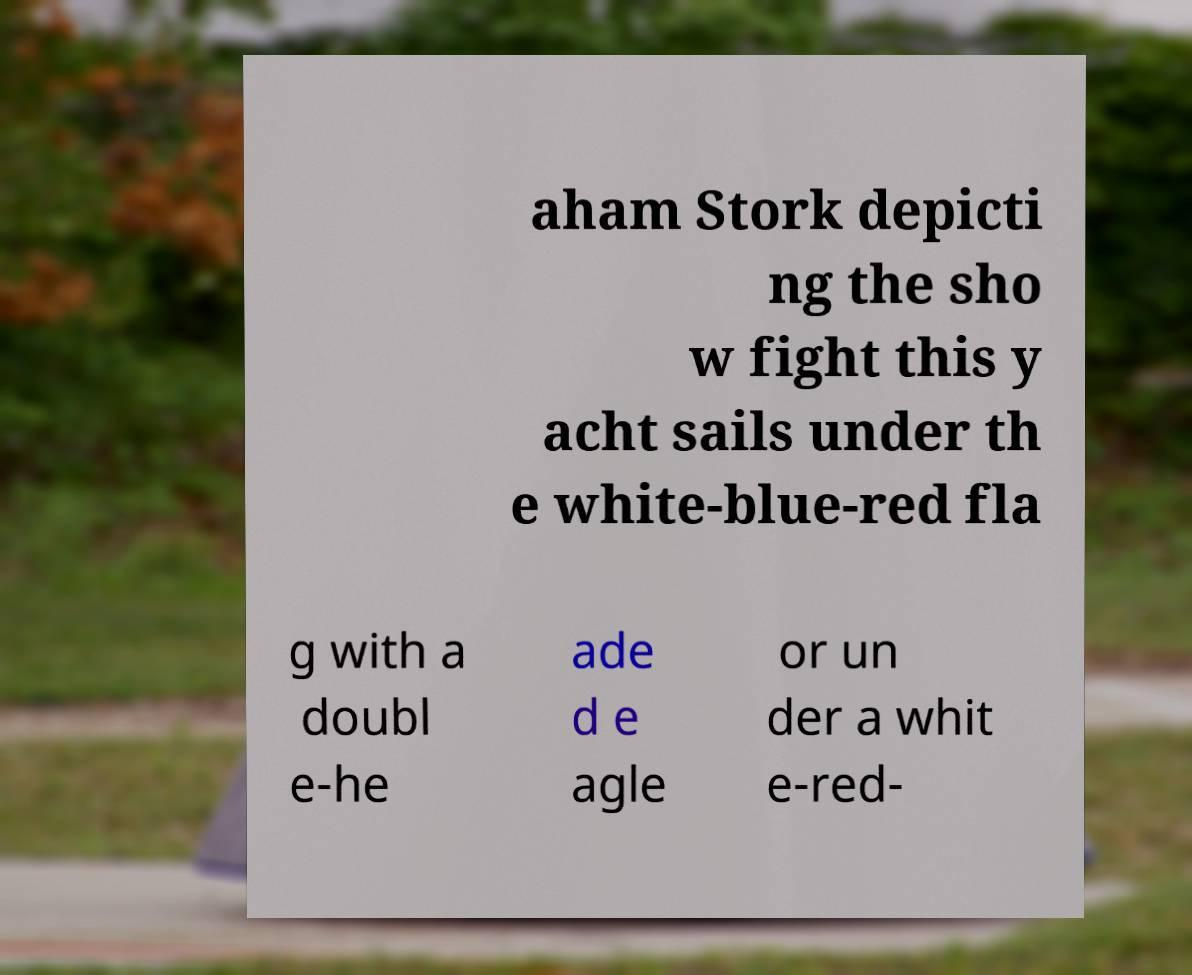Can you read and provide the text displayed in the image?This photo seems to have some interesting text. Can you extract and type it out for me? aham Stork depicti ng the sho w fight this y acht sails under th e white-blue-red fla g with a doubl e-he ade d e agle or un der a whit e-red- 